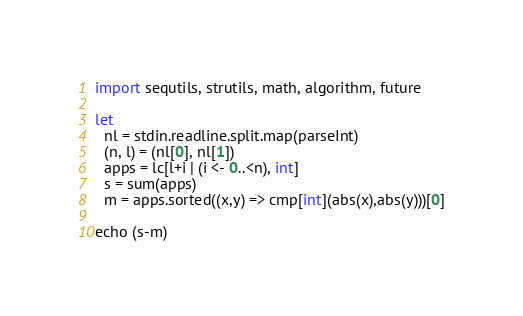Convert code to text. <code><loc_0><loc_0><loc_500><loc_500><_Nim_>import sequtils, strutils, math, algorithm, future

let
  nl = stdin.readline.split.map(parseInt)
  (n, l) = (nl[0], nl[1])
  apps = lc[l+i | (i <- 0..<n), int]
  s = sum(apps)
  m = apps.sorted((x,y) => cmp[int](abs(x),abs(y)))[0]

echo (s-m)
</code> 